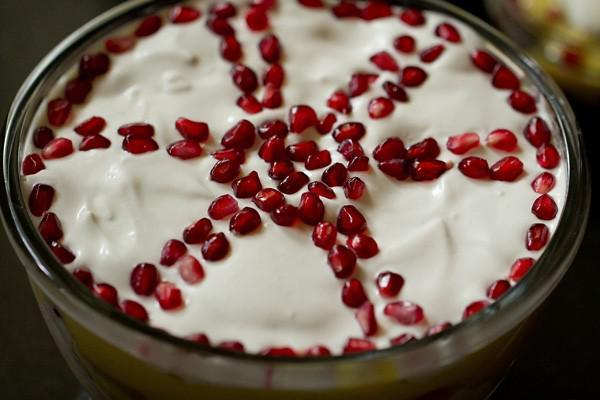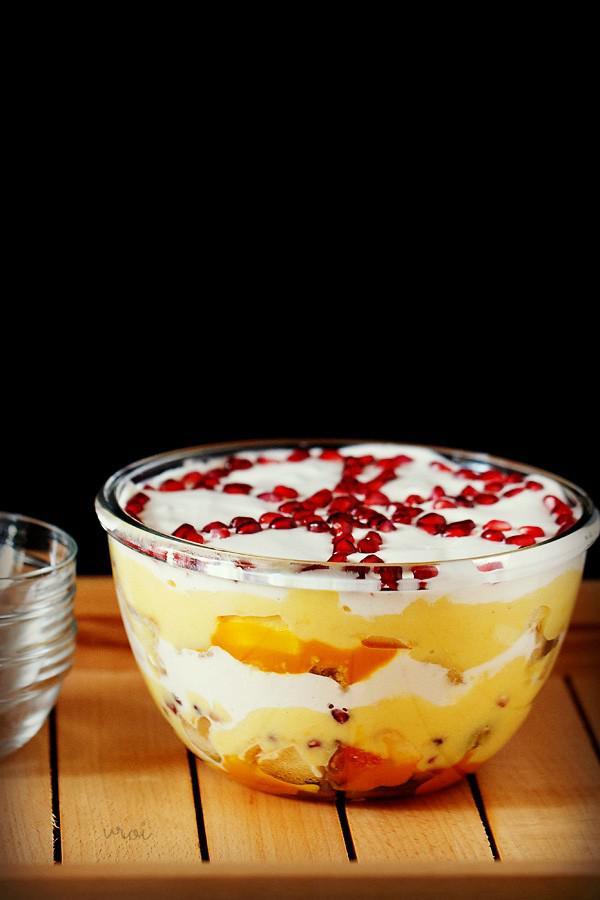The first image is the image on the left, the second image is the image on the right. Given the left and right images, does the statement "In at least one image, an untouched dessert is served in a large bowl, rather than individual serving dishes." hold true? Answer yes or no. Yes. 